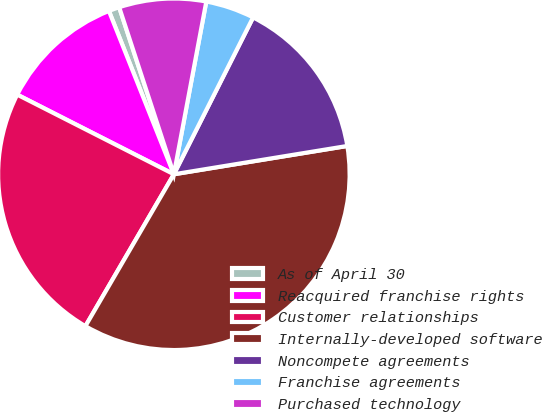Convert chart. <chart><loc_0><loc_0><loc_500><loc_500><pie_chart><fcel>As of April 30<fcel>Reacquired franchise rights<fcel>Customer relationships<fcel>Internally-developed software<fcel>Noncompete agreements<fcel>Franchise agreements<fcel>Purchased technology<nl><fcel>0.99%<fcel>11.49%<fcel>24.09%<fcel>35.97%<fcel>14.98%<fcel>4.49%<fcel>7.99%<nl></chart> 